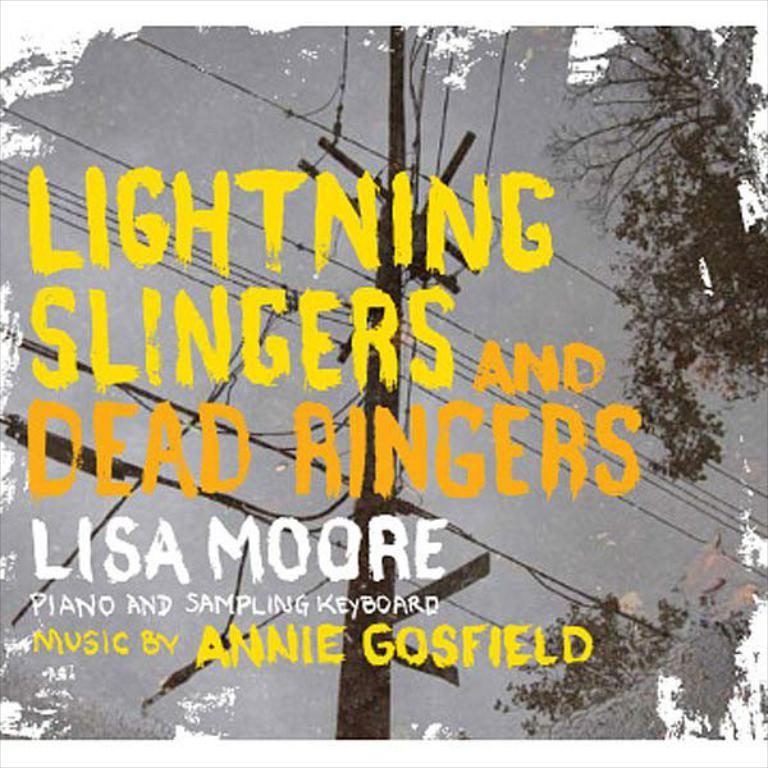What is one of the natural elements visible in the image? The sky is visible in the image. What type of structure can be seen in the image? There is a pole in the image. What is connected to the pole in the image? Transmission wires are visible in the image. What type of vegetation is present in the image? There are trees in the image. What else can be found in the image besides the natural elements and structures? There is some information present in the image. What type of chess piece is located on the top of the pole in the image? There is no chess piece present on the pole in the image. What type of humor can be found in the image? There is no humor present in the image; it is a straightforward depiction of the elements mentioned in the facts. 